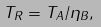Convert formula to latex. <formula><loc_0><loc_0><loc_500><loc_500>T _ { R } = T _ { A } / \eta _ { B } ,</formula> 